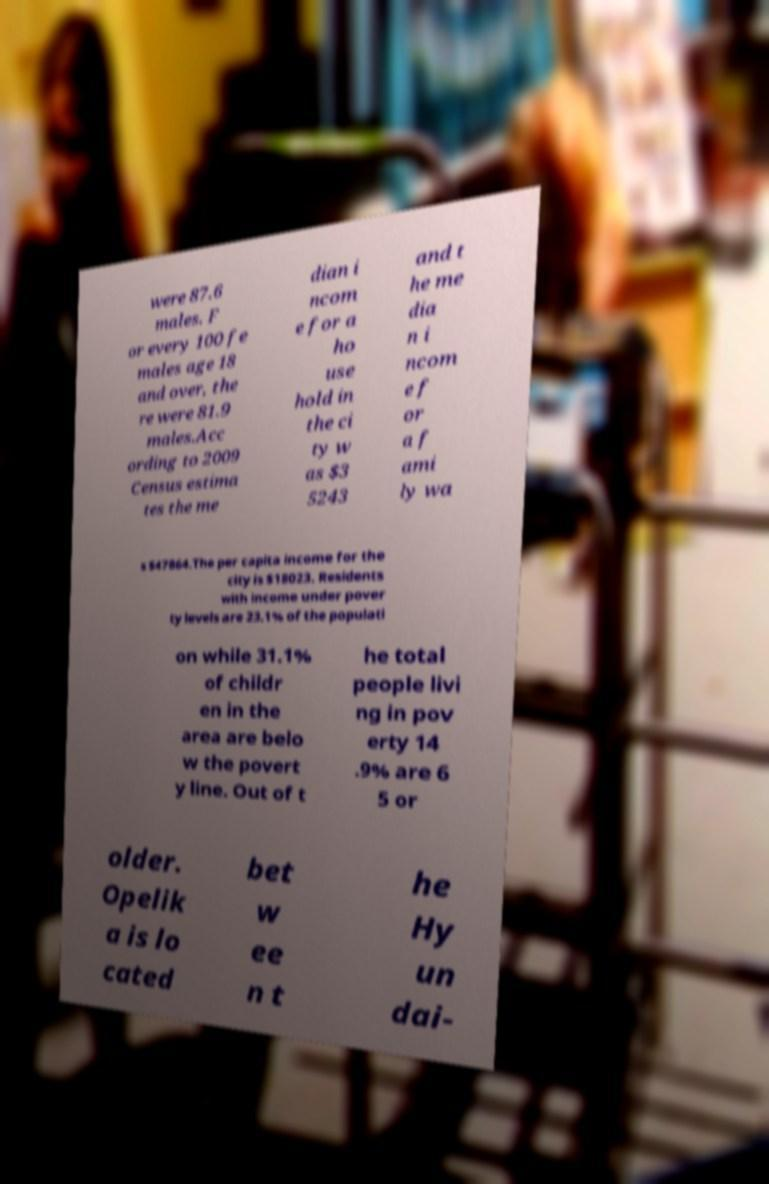Could you extract and type out the text from this image? were 87.6 males. F or every 100 fe males age 18 and over, the re were 81.9 males.Acc ording to 2009 Census estima tes the me dian i ncom e for a ho use hold in the ci ty w as $3 5243 and t he me dia n i ncom e f or a f ami ly wa s $47864.The per capita income for the city is $18023. Residents with income under pover ty levels are 23.1% of the populati on while 31.1% of childr en in the area are belo w the povert y line. Out of t he total people livi ng in pov erty 14 .9% are 6 5 or older. Opelik a is lo cated bet w ee n t he Hy un dai- 